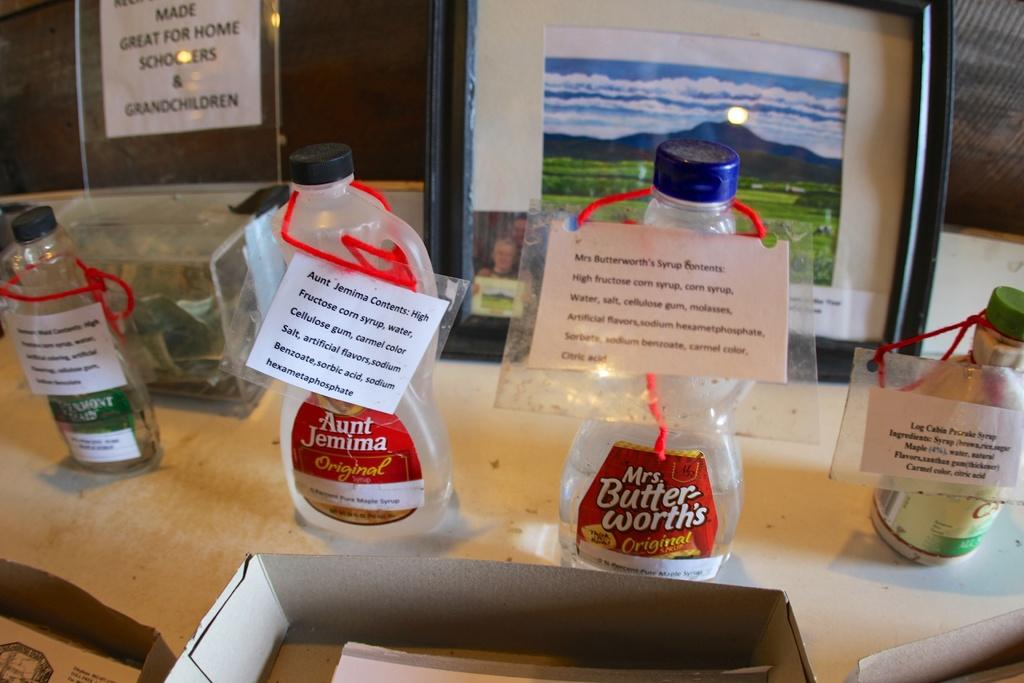<image>
Write a terse but informative summary of the picture. A bottle of Aunt Jemima is next to a bottle of Mrs Butter-worths. 